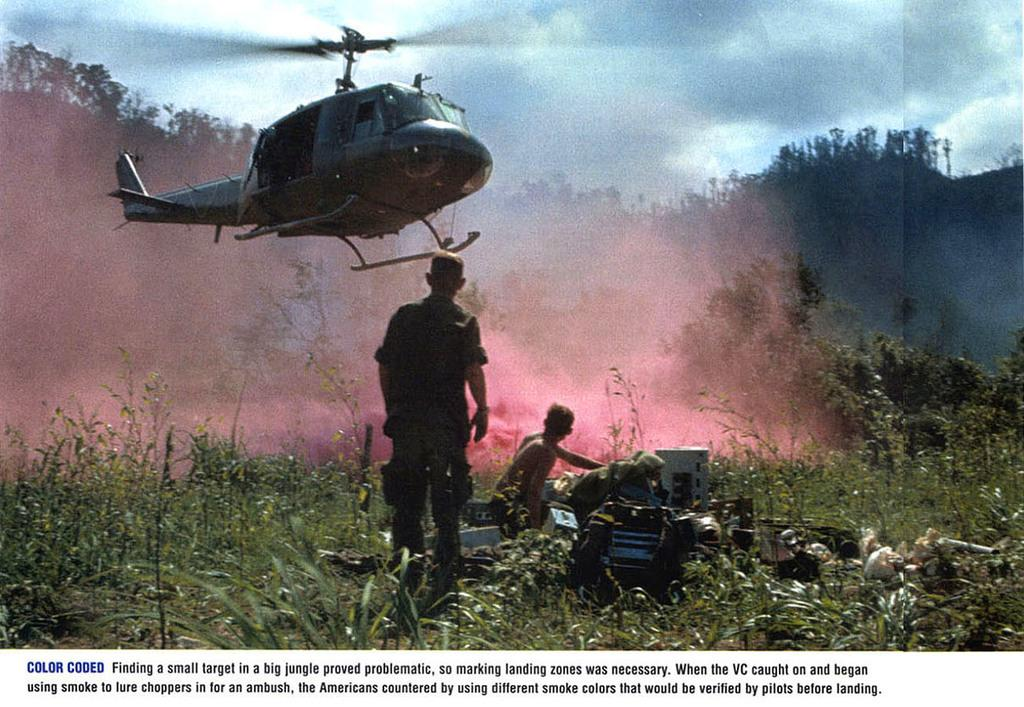<image>
Write a terse but informative summary of the picture. A man looking up at a helicopter in a picture captioned with information about jungle landing zones. 